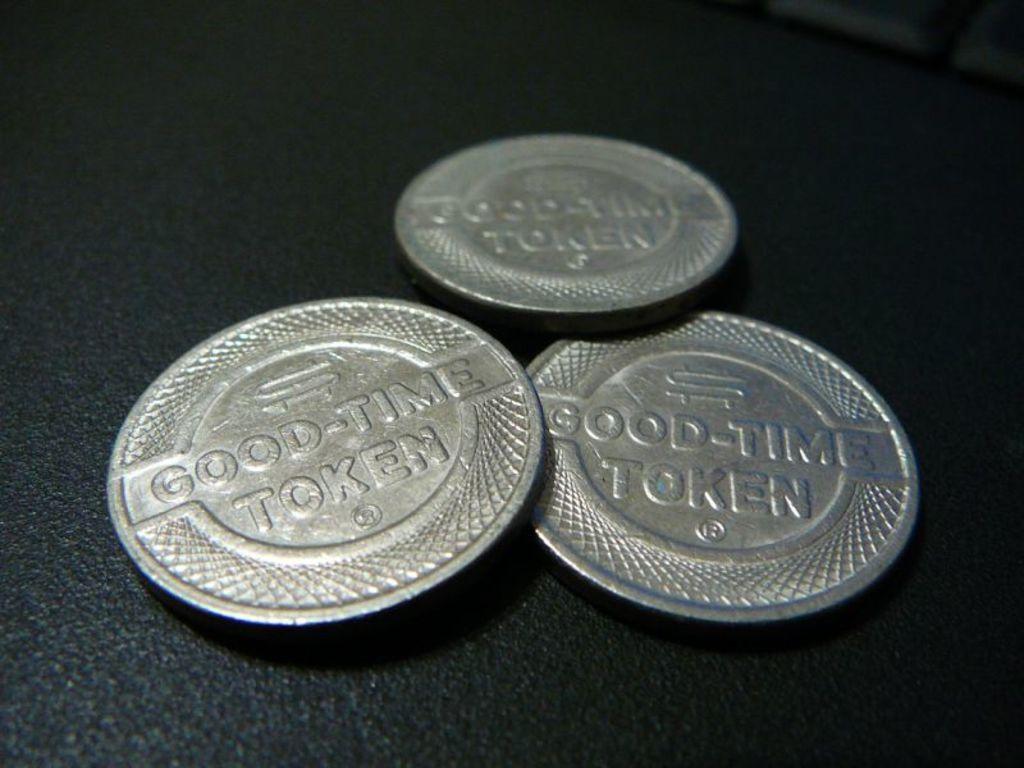What kind of token is this?
Offer a very short reply. Good time token. What kind of time are these tokens for?
Your response must be concise. Good. 